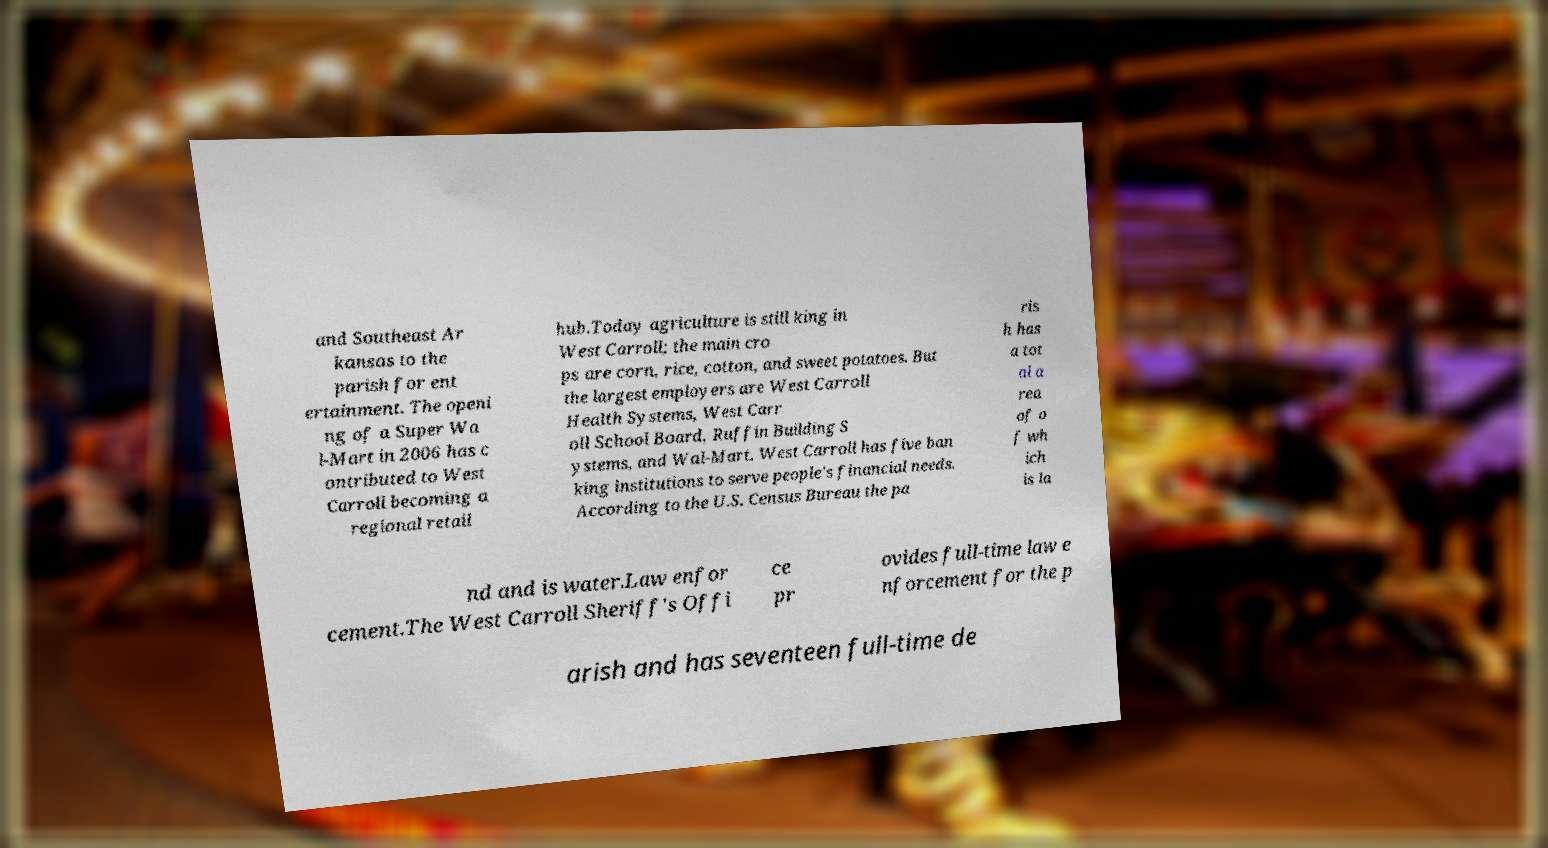Can you read and provide the text displayed in the image?This photo seems to have some interesting text. Can you extract and type it out for me? and Southeast Ar kansas to the parish for ent ertainment. The openi ng of a Super Wa l-Mart in 2006 has c ontributed to West Carroll becoming a regional retail hub.Today agriculture is still king in West Carroll; the main cro ps are corn, rice, cotton, and sweet potatoes. But the largest employers are West Carroll Health Systems, West Carr oll School Board, Ruffin Building S ystems, and Wal-Mart. West Carroll has five ban king institutions to serve people's financial needs. According to the U.S. Census Bureau the pa ris h has a tot al a rea of o f wh ich is la nd and is water.Law enfor cement.The West Carroll Sheriff's Offi ce pr ovides full-time law e nforcement for the p arish and has seventeen full-time de 